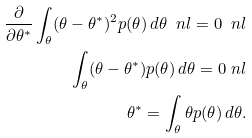Convert formula to latex. <formula><loc_0><loc_0><loc_500><loc_500>\frac { \partial } { \partial \theta ^ { * } } \int _ { \theta } ( \theta - \theta ^ { * } ) ^ { 2 } p ( \theta ) \, d \theta \ n l = 0 \ n l \\ \int _ { \theta } ( \theta - \theta ^ { * } ) p ( \theta ) \, d \theta = 0 \ n l \\ \theta ^ { * } = \int _ { \theta } \theta p ( \theta ) \, d \theta .</formula> 